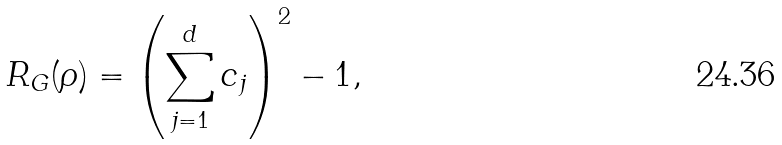Convert formula to latex. <formula><loc_0><loc_0><loc_500><loc_500>R _ { G } ( \rho ) = \left ( \sum _ { j = 1 } ^ { d } c _ { j } \right ) ^ { 2 } - 1 ,</formula> 